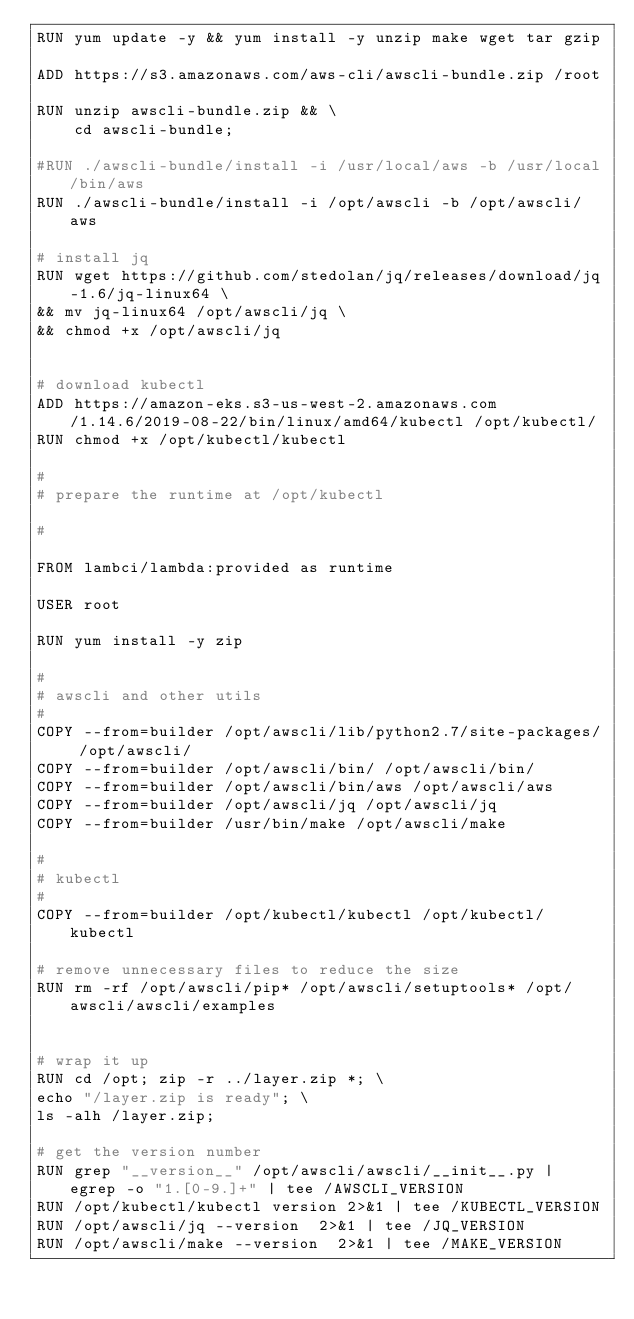<code> <loc_0><loc_0><loc_500><loc_500><_Dockerfile_>RUN yum update -y && yum install -y unzip make wget tar gzip

ADD https://s3.amazonaws.com/aws-cli/awscli-bundle.zip /root

RUN unzip awscli-bundle.zip && \
    cd awscli-bundle;
    
#RUN ./awscli-bundle/install -i /usr/local/aws -b /usr/local/bin/aws
RUN ./awscli-bundle/install -i /opt/awscli -b /opt/awscli/aws
  
# install jq
RUN wget https://github.com/stedolan/jq/releases/download/jq-1.6/jq-linux64 \
&& mv jq-linux64 /opt/awscli/jq \
&& chmod +x /opt/awscli/jq


# download kubectl
ADD https://amazon-eks.s3-us-west-2.amazonaws.com/1.14.6/2019-08-22/bin/linux/amd64/kubectl /opt/kubectl/
RUN chmod +x /opt/kubectl/kubectl

#
# prepare the runtime at /opt/kubectl

#
  
FROM lambci/lambda:provided as runtime

USER root

RUN yum install -y zip 

#
# awscli and other utils
#
COPY --from=builder /opt/awscli/lib/python2.7/site-packages/ /opt/awscli/ 
COPY --from=builder /opt/awscli/bin/ /opt/awscli/bin/ 
COPY --from=builder /opt/awscli/bin/aws /opt/awscli/aws
COPY --from=builder /opt/awscli/jq /opt/awscli/jq
COPY --from=builder /usr/bin/make /opt/awscli/make

#
# kubectl
#
COPY --from=builder /opt/kubectl/kubectl /opt/kubectl/kubectl

# remove unnecessary files to reduce the size
RUN rm -rf /opt/awscli/pip* /opt/awscli/setuptools* /opt/awscli/awscli/examples


# wrap it up
RUN cd /opt; zip -r ../layer.zip *; \
echo "/layer.zip is ready"; \
ls -alh /layer.zip;

# get the version number
RUN grep "__version__" /opt/awscli/awscli/__init__.py | egrep -o "1.[0-9.]+" | tee /AWSCLI_VERSION
RUN /opt/kubectl/kubectl version 2>&1 | tee /KUBECTL_VERSION
RUN /opt/awscli/jq --version  2>&1 | tee /JQ_VERSION
RUN /opt/awscli/make --version  2>&1 | tee /MAKE_VERSION
</code> 